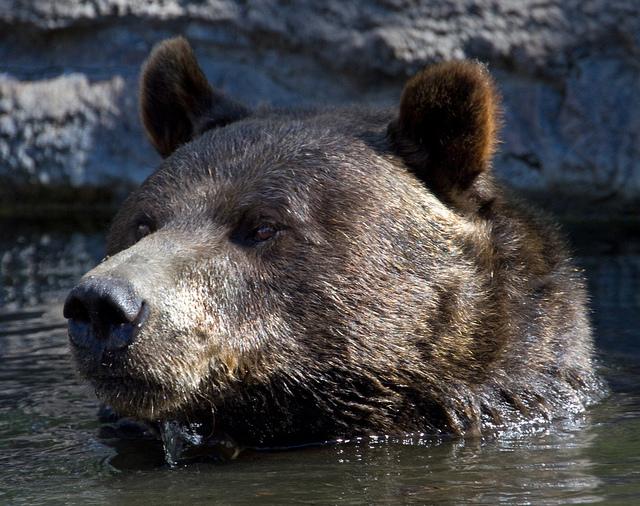Where is the bear?
Quick response, please. Water. Is the bear happy in the water?
Keep it brief. Yes. Is the bear swimming?
Be succinct. Yes. Does the bear have claws?
Give a very brief answer. Yes. How many eyes can be seen?
Give a very brief answer. 2. What portion of the bear is visible?
Keep it brief. Head. Is the water clean or dirty?
Write a very short answer. Dirty. Is the bear looking at the photographer?
Answer briefly. No. 